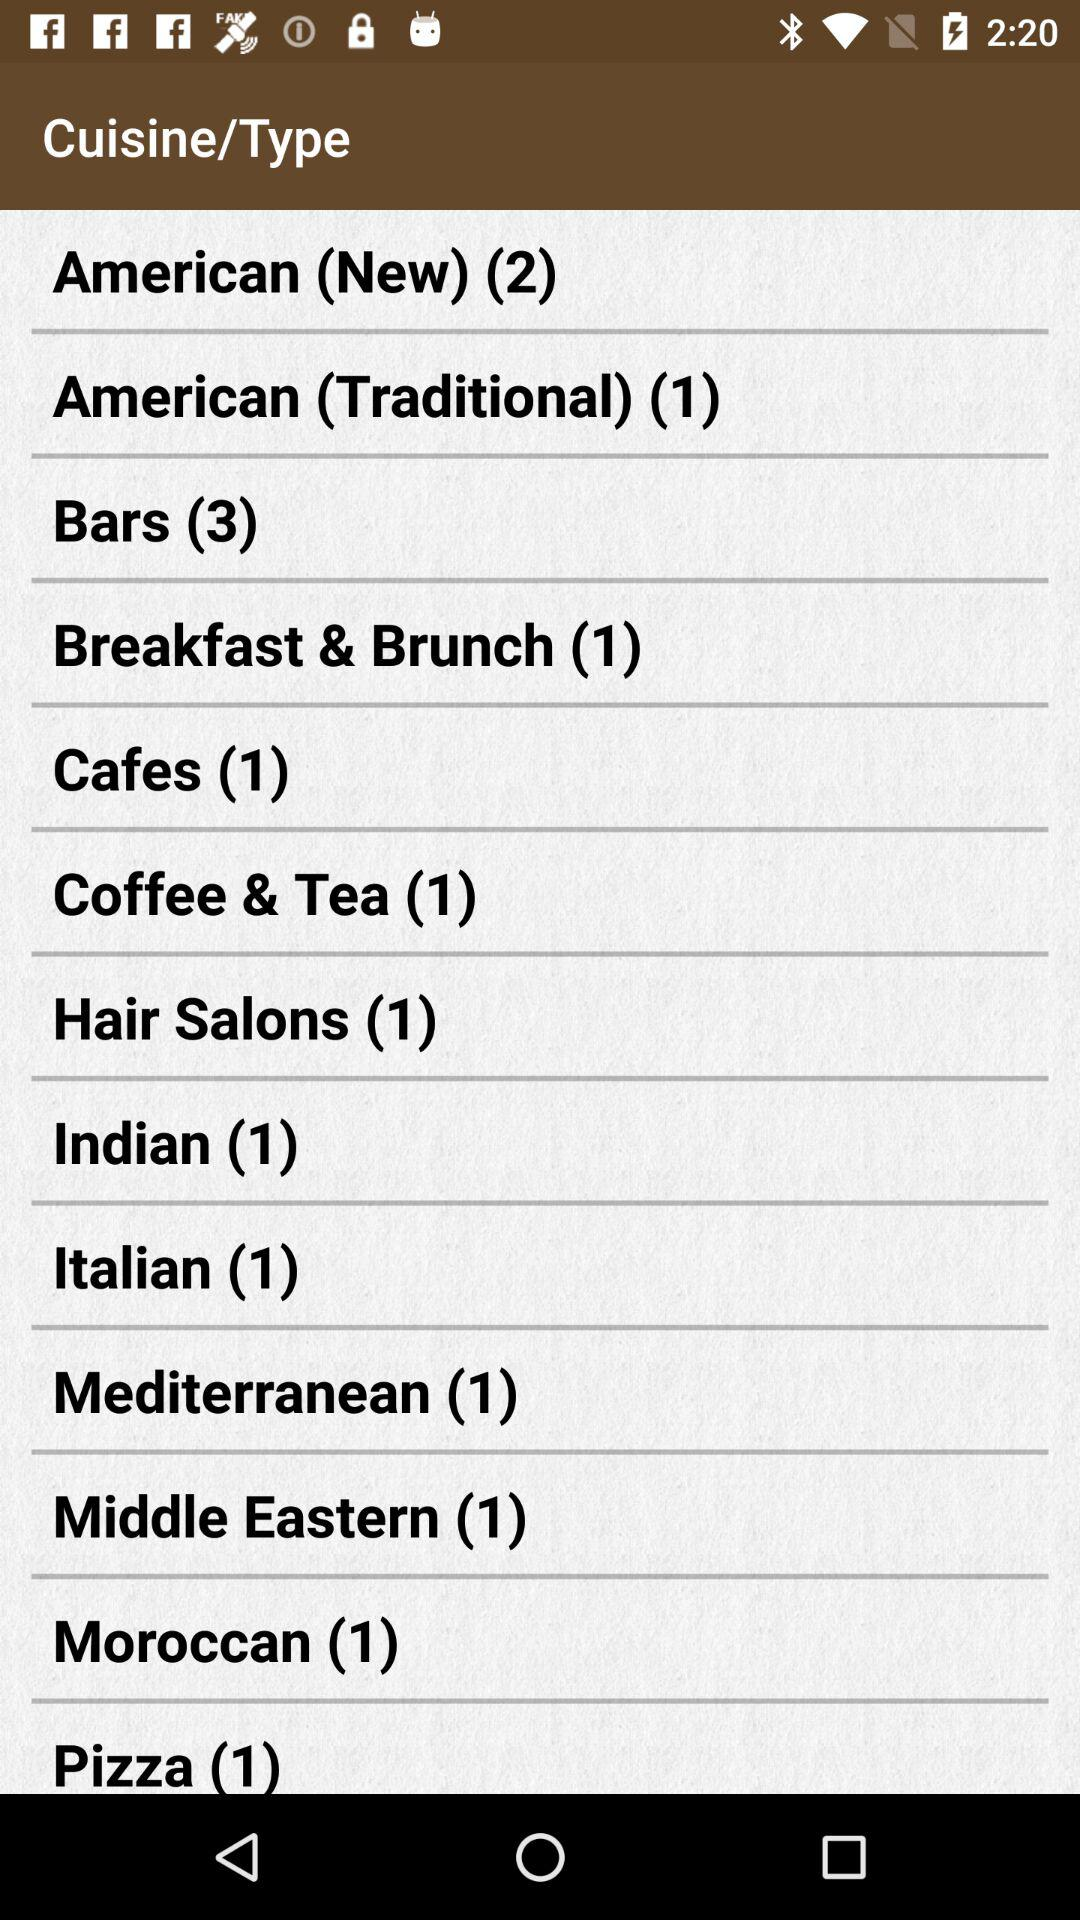What's the count of Italian cuisine? The count is 1. 